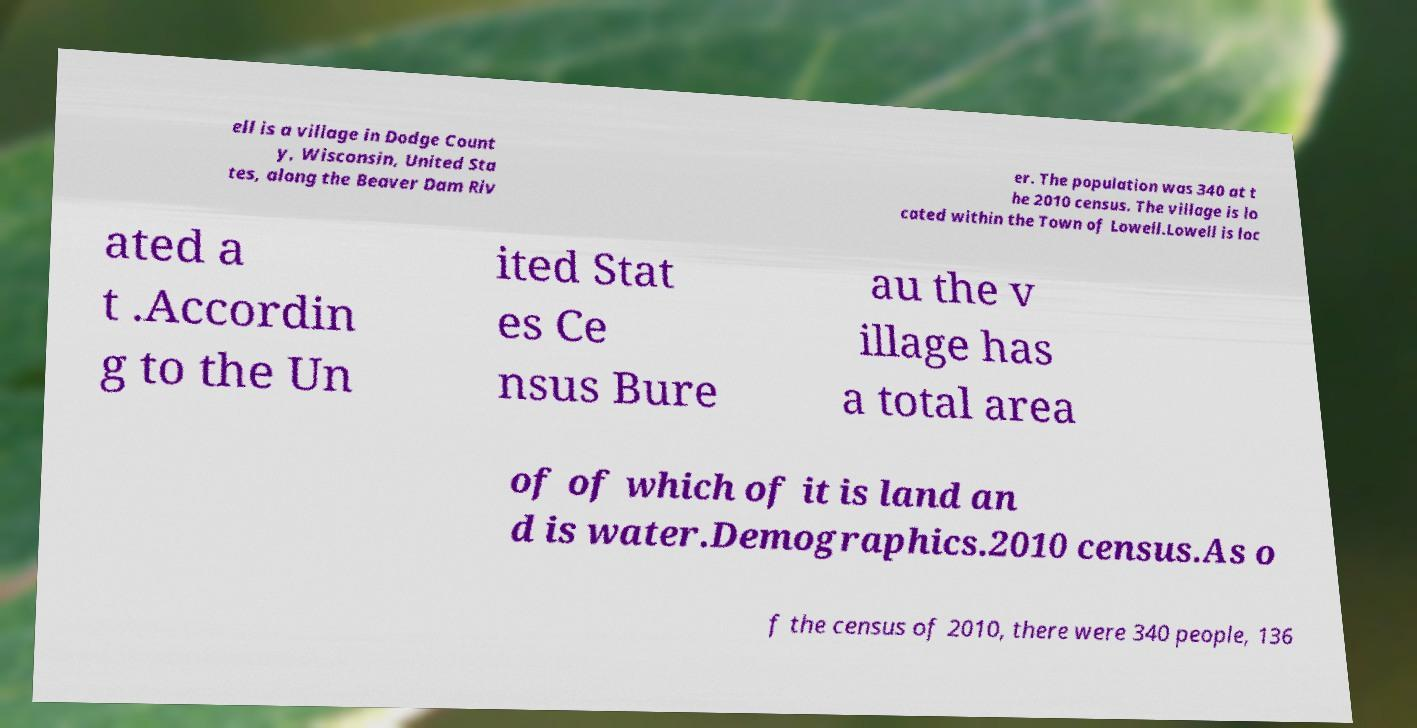Can you read and provide the text displayed in the image?This photo seems to have some interesting text. Can you extract and type it out for me? ell is a village in Dodge Count y, Wisconsin, United Sta tes, along the Beaver Dam Riv er. The population was 340 at t he 2010 census. The village is lo cated within the Town of Lowell.Lowell is loc ated a t .Accordin g to the Un ited Stat es Ce nsus Bure au the v illage has a total area of of which of it is land an d is water.Demographics.2010 census.As o f the census of 2010, there were 340 people, 136 